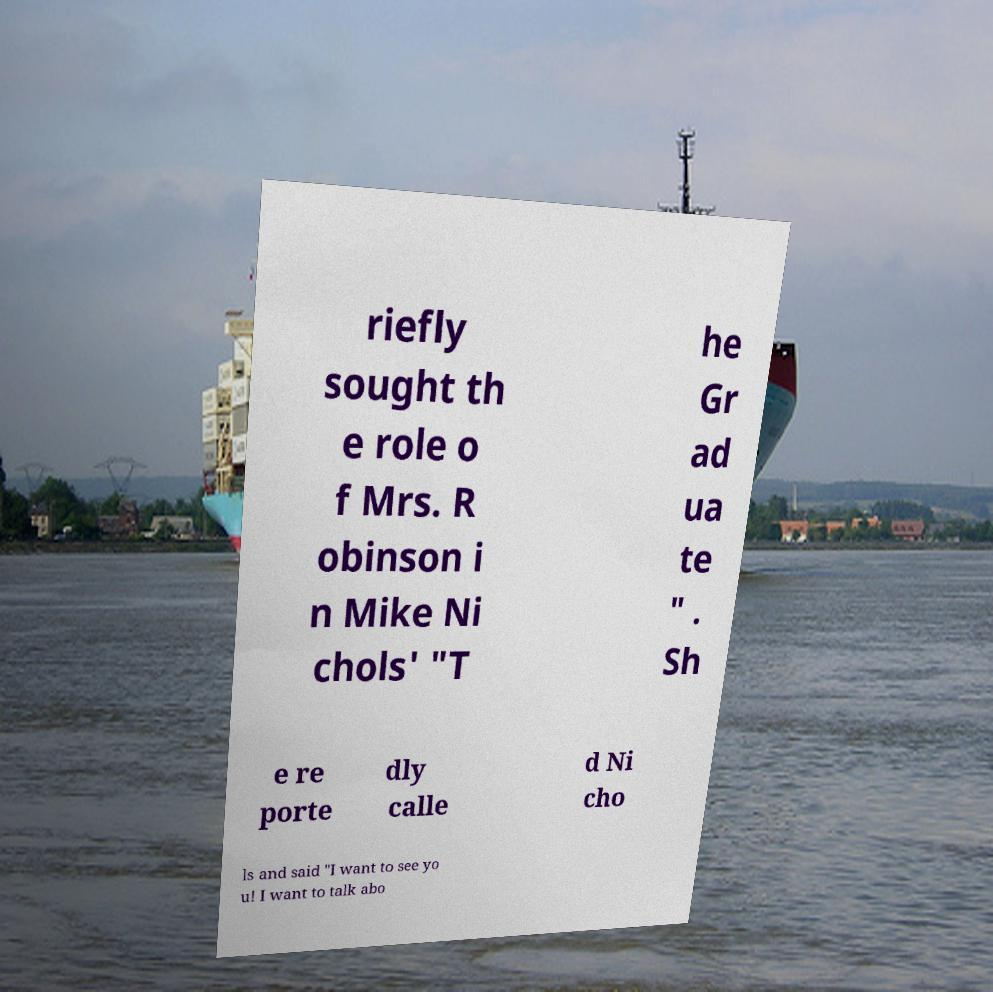Please read and relay the text visible in this image. What does it say? riefly sought th e role o f Mrs. R obinson i n Mike Ni chols' "T he Gr ad ua te " . Sh e re porte dly calle d Ni cho ls and said "I want to see yo u! I want to talk abo 